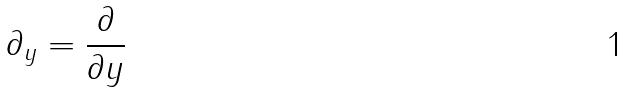<formula> <loc_0><loc_0><loc_500><loc_500>\partial _ { y } = \frac { \partial } { \partial y }</formula> 